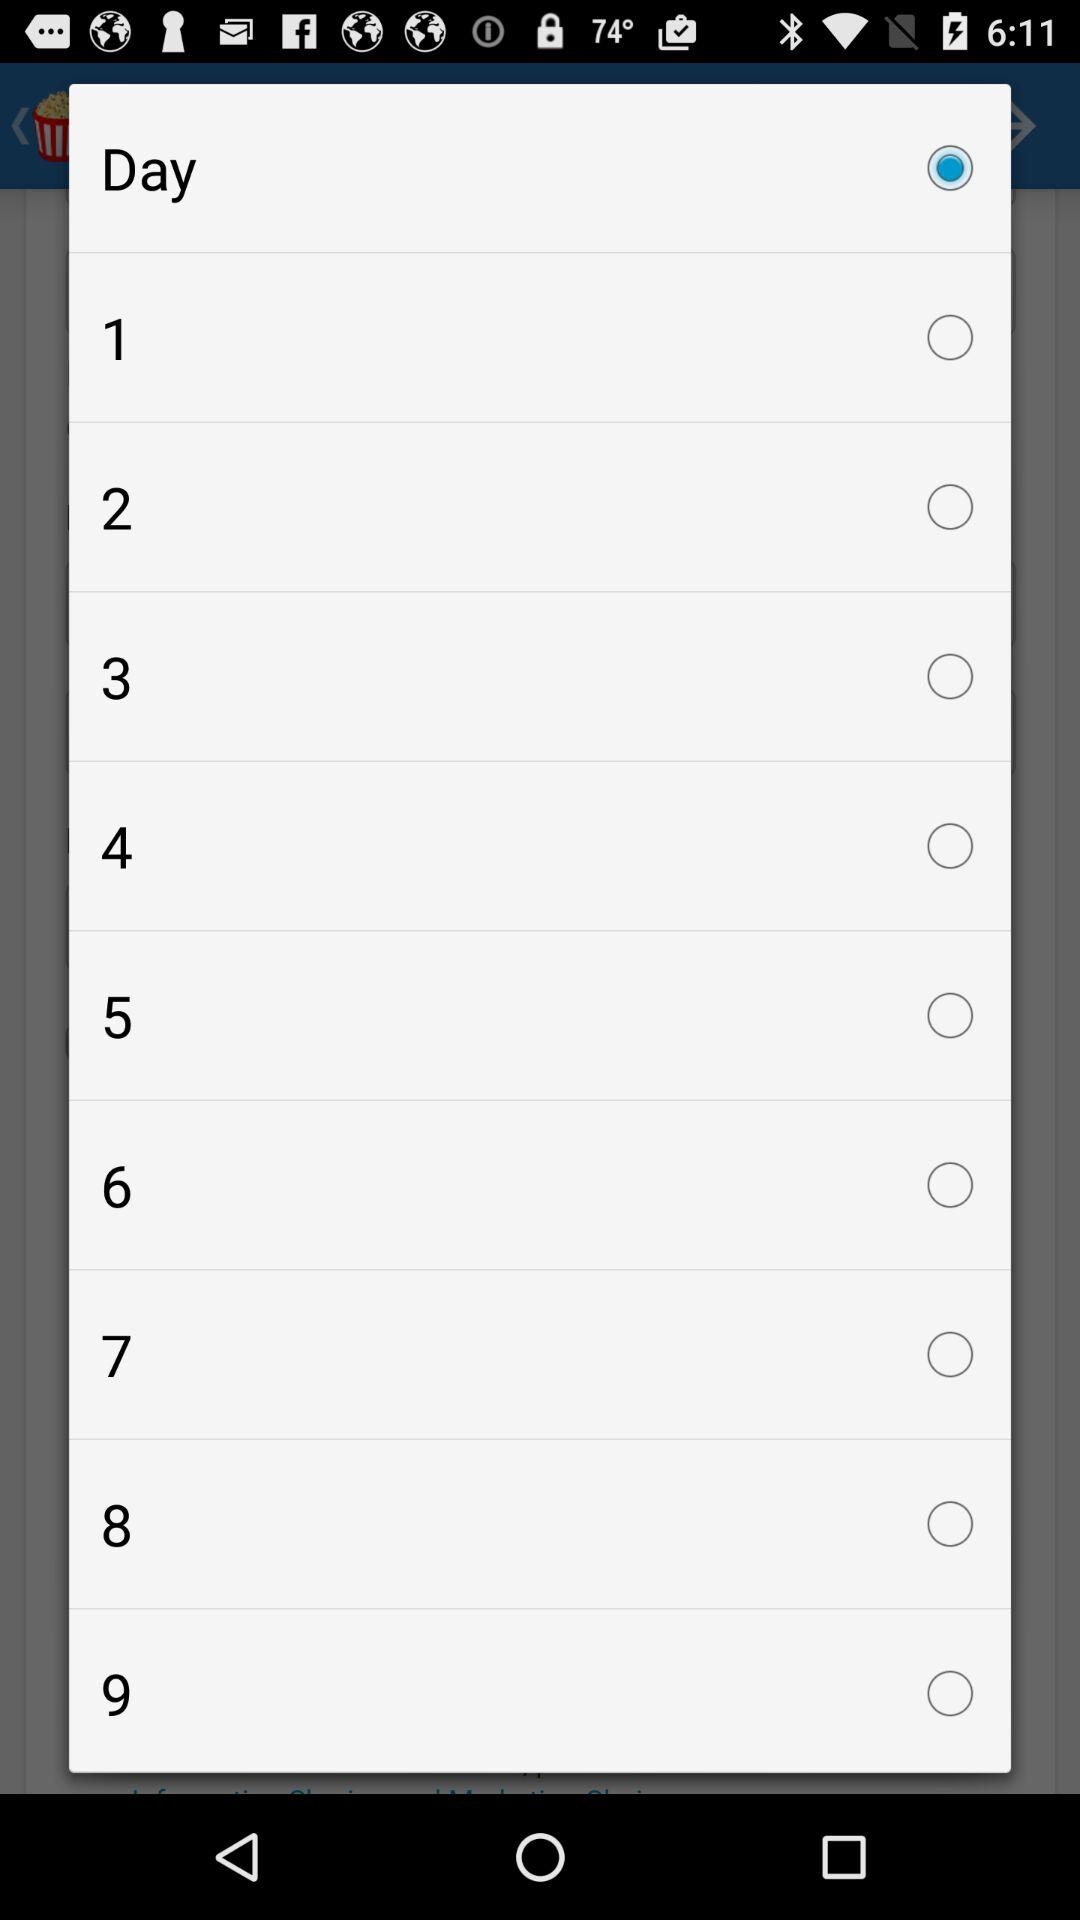What is the selected option? The selected option is day. 